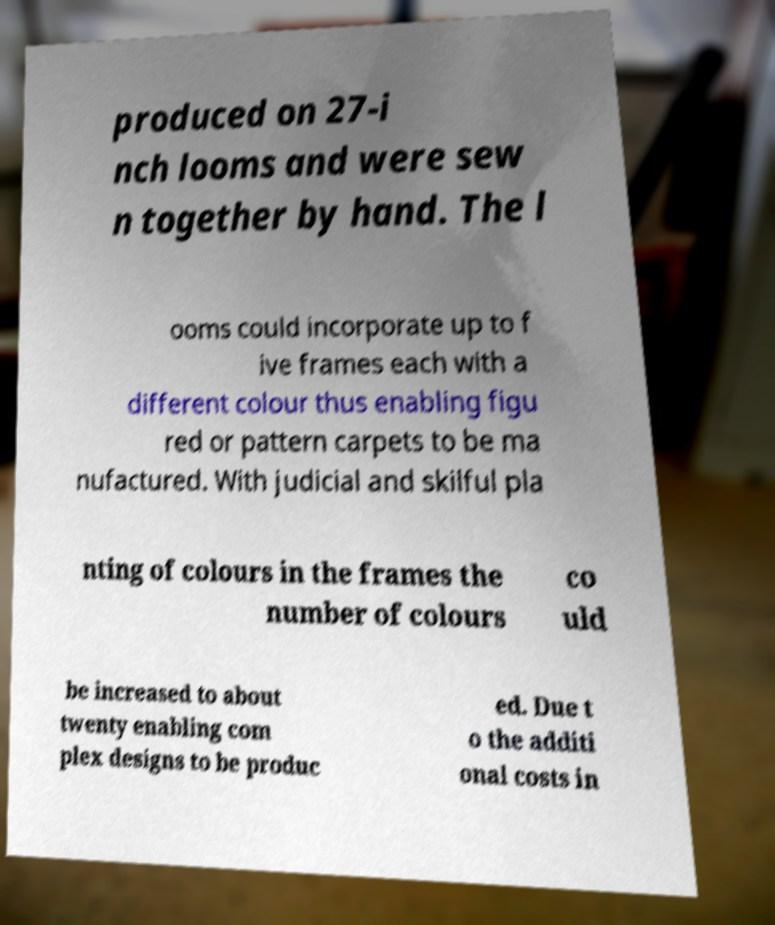Please identify and transcribe the text found in this image. produced on 27-i nch looms and were sew n together by hand. The l ooms could incorporate up to f ive frames each with a different colour thus enabling figu red or pattern carpets to be ma nufactured. With judicial and skilful pla nting of colours in the frames the number of colours co uld be increased to about twenty enabling com plex designs to be produc ed. Due t o the additi onal costs in 